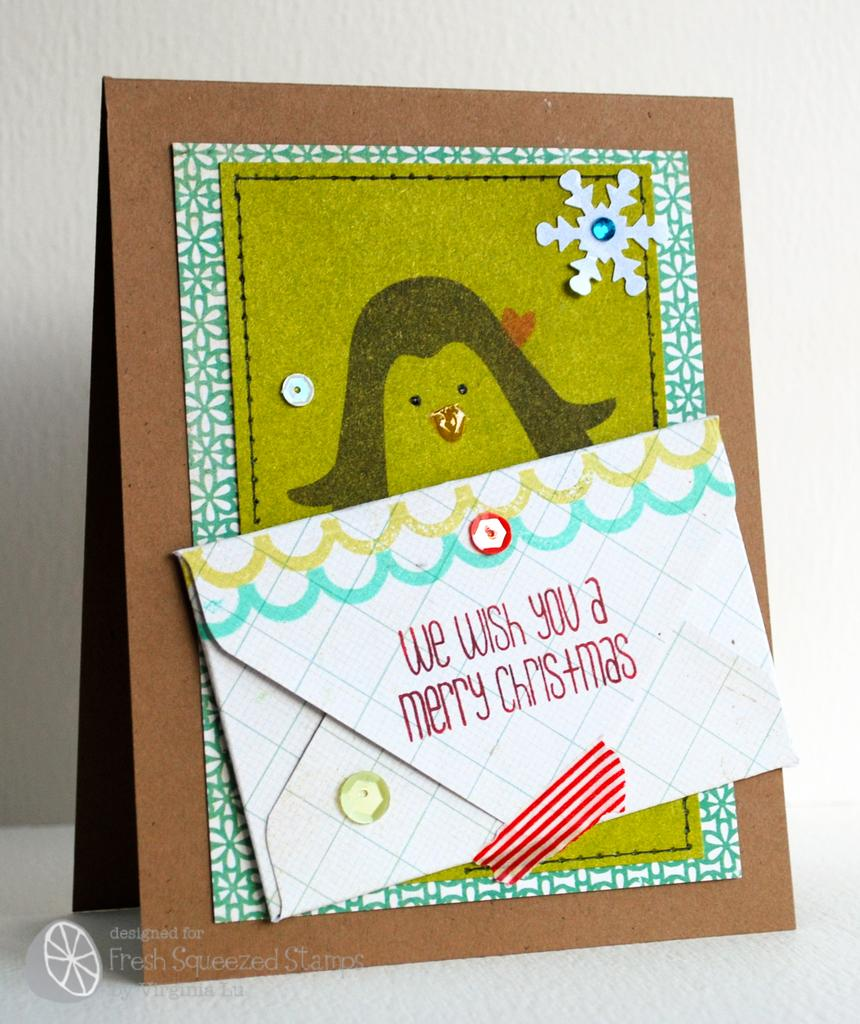Provide a one-sentence caption for the provided image. A Christmas card with a penguin drawn on the front is displayed. 